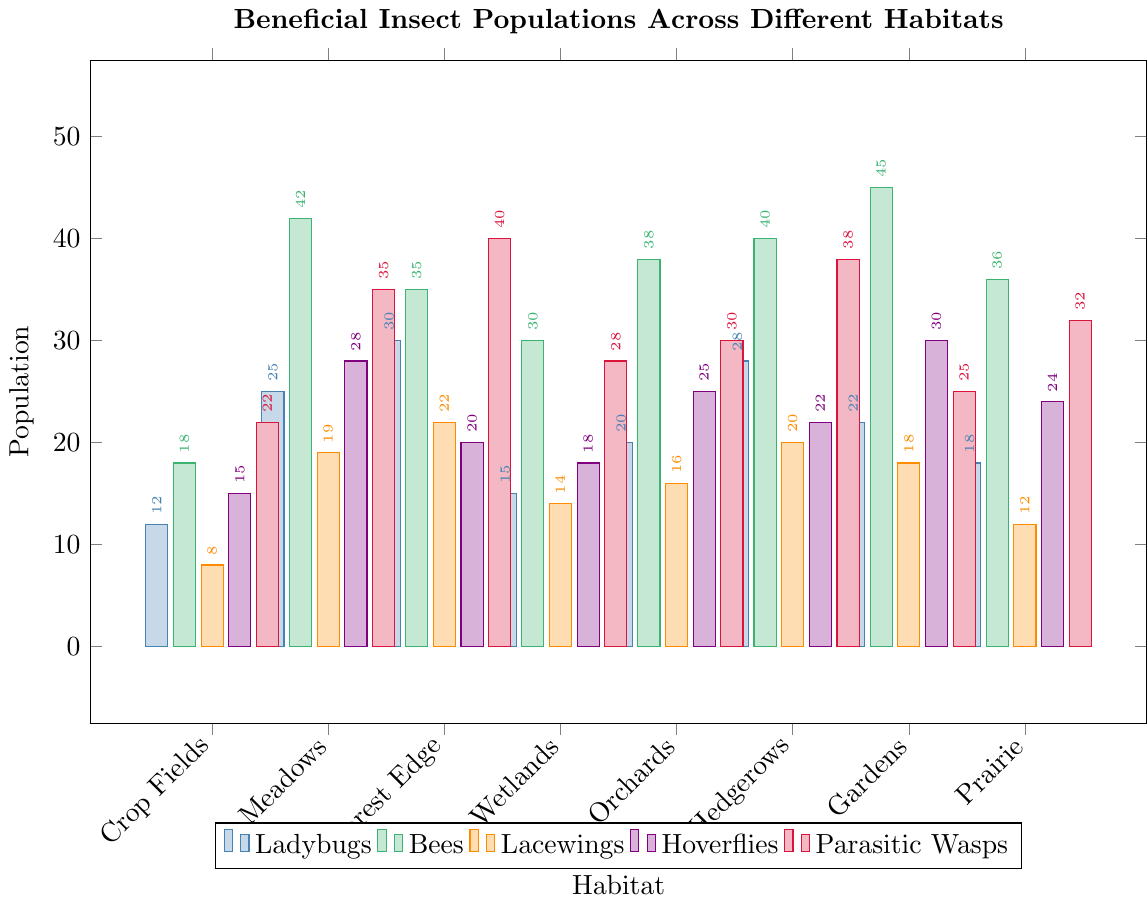Which habitat has the highest population of bees? Refer to the bees category and compare the heights of the bars across all habitats. The bar for Gardens is the tallest for bees with a count of 45.
Answer: Gardens Which habitat has more hoverflies: Wetlands or Hedgerows? Compare the height of the bars for hoverflies in Wetlands and Hedgerows. Wetlands have 18 hoverflies, while Hedgerows have 22.
Answer: Hedgerows What is the average population of ladybugs across all habitats? Sum up the ladybug populations for all habitats and divide by the number of habitats. (12 + 25 + 30 + 15 + 20 + 28 + 22 + 18) / 8 = 170 / 8 = 21.25
Answer: 21.25 Which beneficial insect has the highest population in Prairie? Look at the Prairie section and identify the largest value among ladybugs (18), bees (36), lacewings (12), hoverflies (24), and parasitic wasps (32).
Answer: Bees Compare the population of parasitic wasps in Forest Edge and Crop Fields. Which one is larger and by how much? Subtract the population of parasitic wasps in Crop Fields from that in Forest Edge. (40 - 22 = 18)
Answer: Forest Edge by 18 What is the least populated beneficial insect in Meadows? Compare the populations of all insects in Meadows and find the lowest value. Ladybugs (25), bees (42), lacewings (19), hoverflies (28), and parasitic wasps (35). Lacewings are the least populated.
Answer: Lacewings How many more ladybugs are there in Meadows compared to Crop Fields? Subtract the population of ladybugs in Crop Fields from that in Meadows. (25 - 12 = 13)
Answer: 13 What is the total population of lacewings and hoverflies in Gardens? Add the populations of lacewings and hoverflies in Gardens. (18 + 30 = 48)
Answer: 48 What is the combined population of all beneficial insects in Orchards? Sum up the populations of all insect categories in Orchards. (20 + 38 + 16 + 25 + 30 = 129)
Answer: 129 